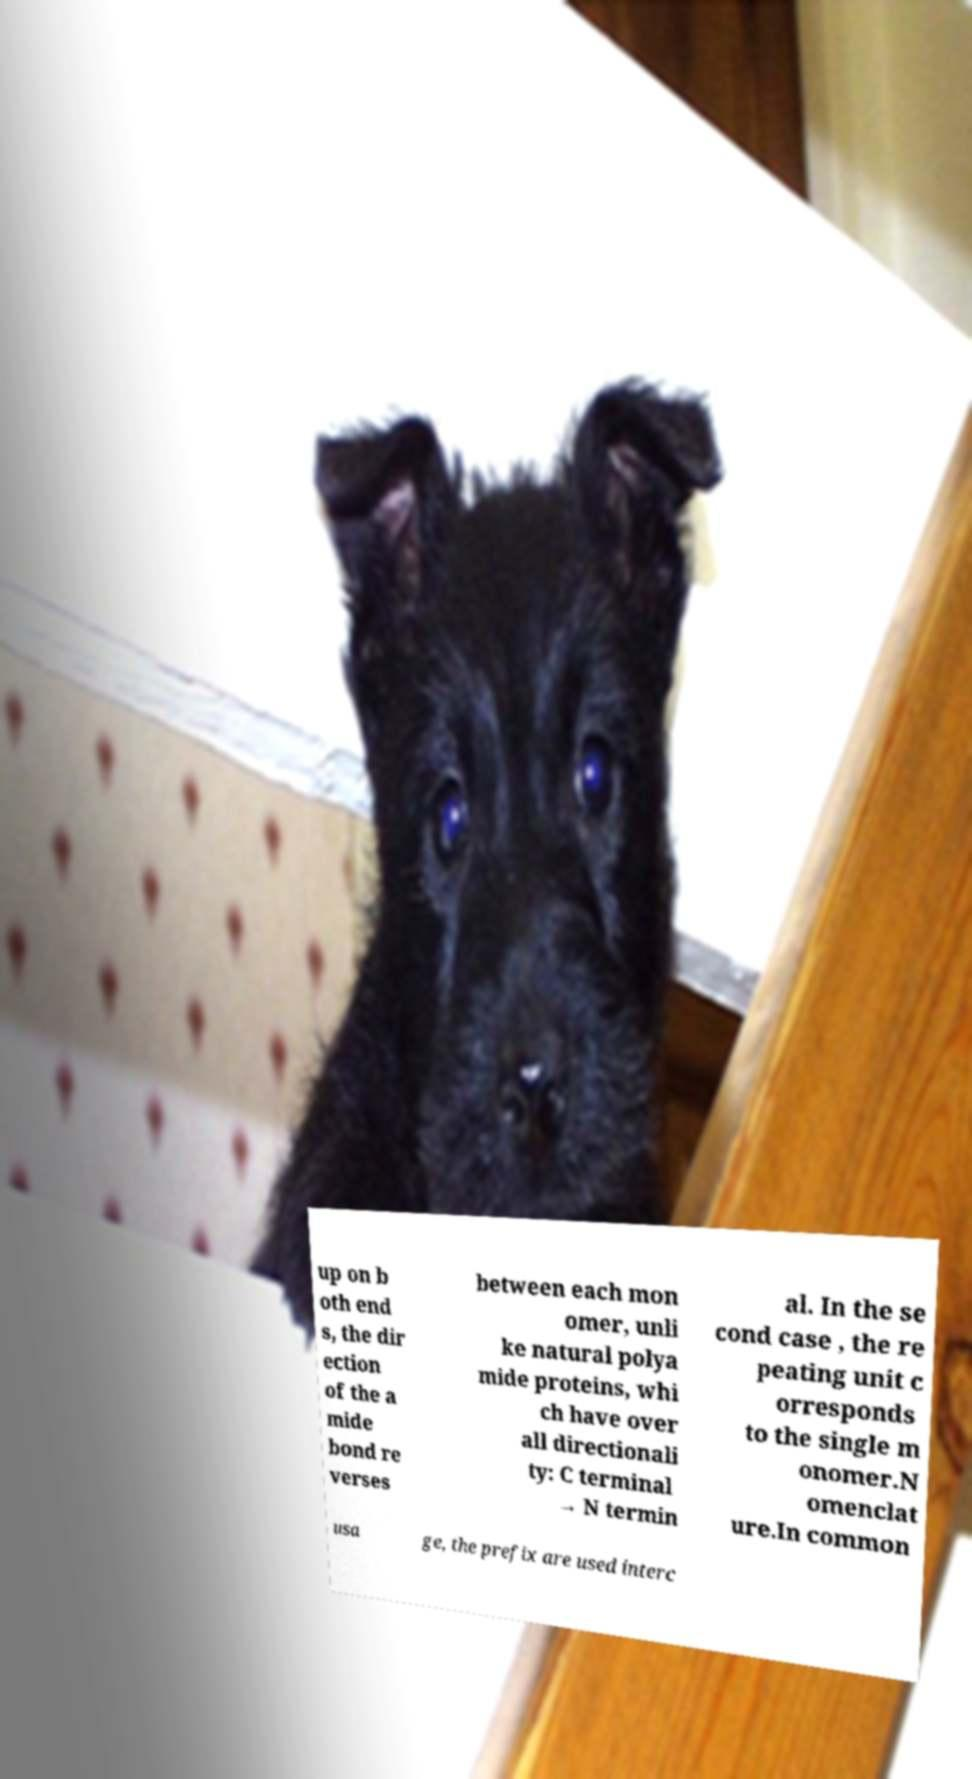Please read and relay the text visible in this image. What does it say? up on b oth end s, the dir ection of the a mide bond re verses between each mon omer, unli ke natural polya mide proteins, whi ch have over all directionali ty: C terminal → N termin al. In the se cond case , the re peating unit c orresponds to the single m onomer.N omenclat ure.In common usa ge, the prefix are used interc 